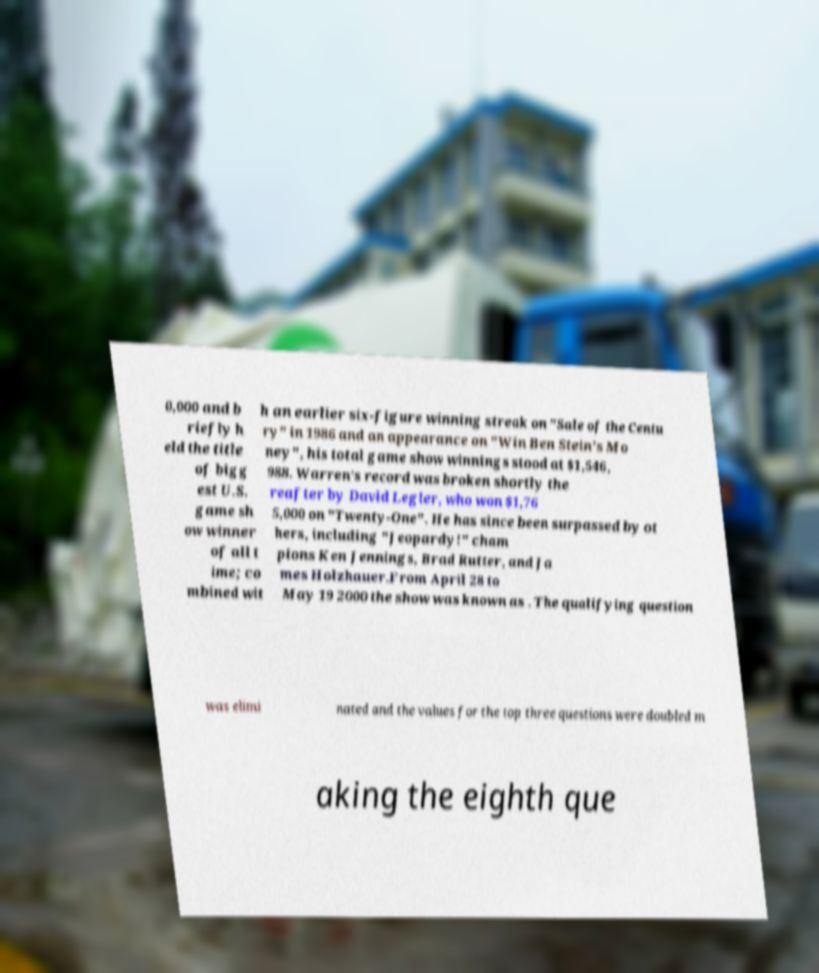Could you extract and type out the text from this image? 0,000 and b riefly h eld the title of bigg est U.S. game sh ow winner of all t ime; co mbined wit h an earlier six-figure winning streak on "Sale of the Centu ry" in 1986 and an appearance on "Win Ben Stein's Mo ney", his total game show winnings stood at $1,546, 988. Warren's record was broken shortly the reafter by David Legler, who won $1,76 5,000 on "Twenty-One". He has since been surpassed by ot hers, including "Jeopardy!" cham pions Ken Jennings, Brad Rutter, and Ja mes Holzhauer.From April 28 to May 19 2000 the show was known as . The qualifying question was elimi nated and the values for the top three questions were doubled m aking the eighth que 